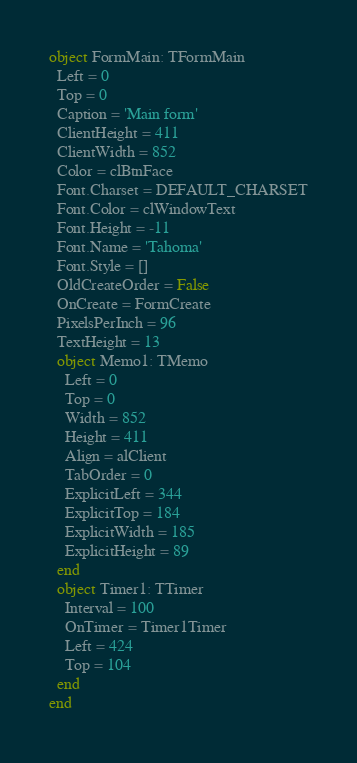<code> <loc_0><loc_0><loc_500><loc_500><_Pascal_>object FormMain: TFormMain
  Left = 0
  Top = 0
  Caption = 'Main form'
  ClientHeight = 411
  ClientWidth = 852
  Color = clBtnFace
  Font.Charset = DEFAULT_CHARSET
  Font.Color = clWindowText
  Font.Height = -11
  Font.Name = 'Tahoma'
  Font.Style = []
  OldCreateOrder = False
  OnCreate = FormCreate
  PixelsPerInch = 96
  TextHeight = 13
  object Memo1: TMemo
    Left = 0
    Top = 0
    Width = 852
    Height = 411
    Align = alClient
    TabOrder = 0
    ExplicitLeft = 344
    ExplicitTop = 184
    ExplicitWidth = 185
    ExplicitHeight = 89
  end
  object Timer1: TTimer
    Interval = 100
    OnTimer = Timer1Timer
    Left = 424
    Top = 104
  end
end
</code> 